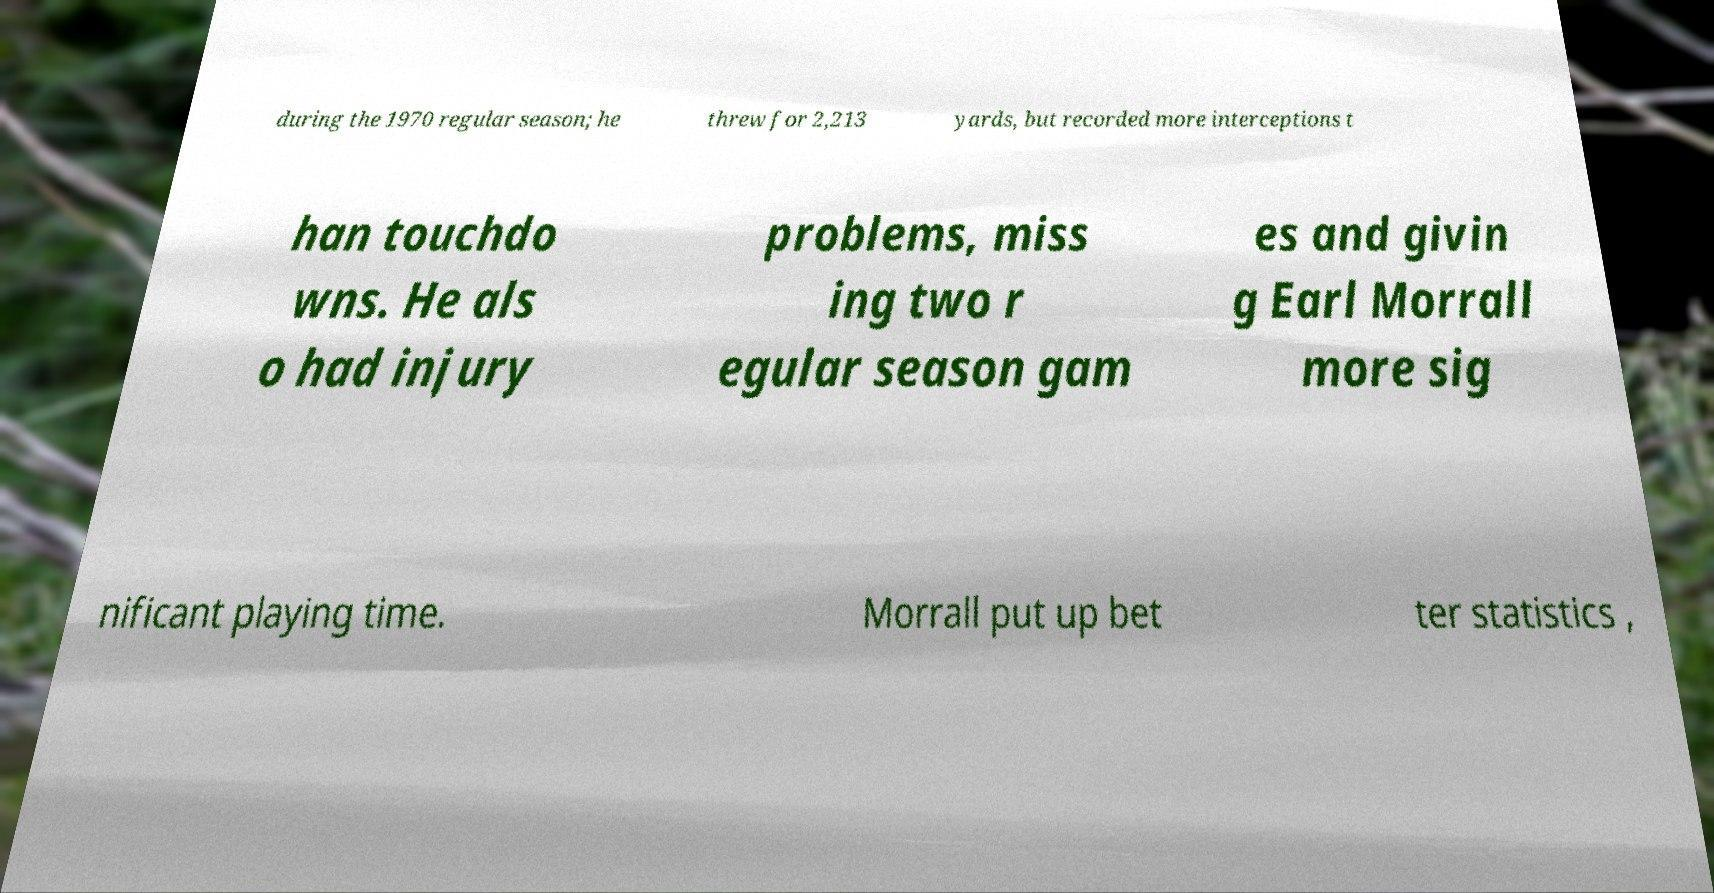Can you read and provide the text displayed in the image?This photo seems to have some interesting text. Can you extract and type it out for me? during the 1970 regular season; he threw for 2,213 yards, but recorded more interceptions t han touchdo wns. He als o had injury problems, miss ing two r egular season gam es and givin g Earl Morrall more sig nificant playing time. Morrall put up bet ter statistics , 